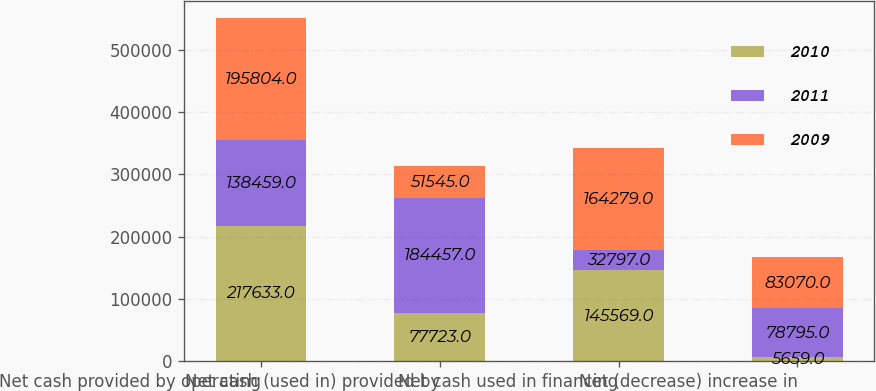Convert chart to OTSL. <chart><loc_0><loc_0><loc_500><loc_500><stacked_bar_chart><ecel><fcel>Net cash provided by operating<fcel>Net cash (used in) provided by<fcel>Net cash used in financing<fcel>Net (decrease) increase in<nl><fcel>2010<fcel>217633<fcel>77723<fcel>145569<fcel>5659<nl><fcel>2011<fcel>138459<fcel>184457<fcel>32797<fcel>78795<nl><fcel>2009<fcel>195804<fcel>51545<fcel>164279<fcel>83070<nl></chart> 